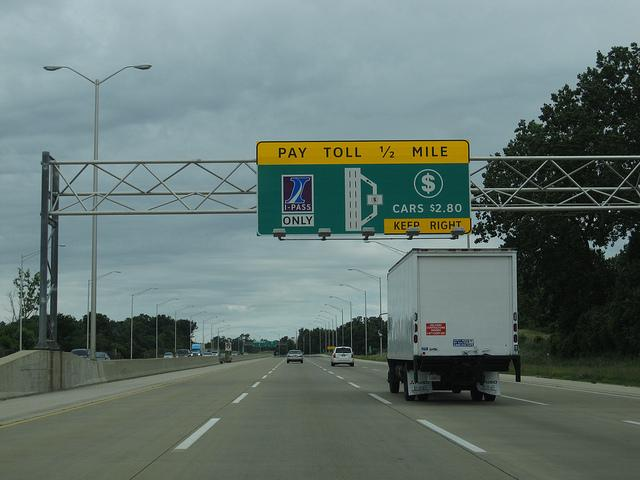What company handles the event that will happen in 1/2 mile?

Choices:
A) ez pass
B) secret service
C) ny mets
D) ny jets ez pass 